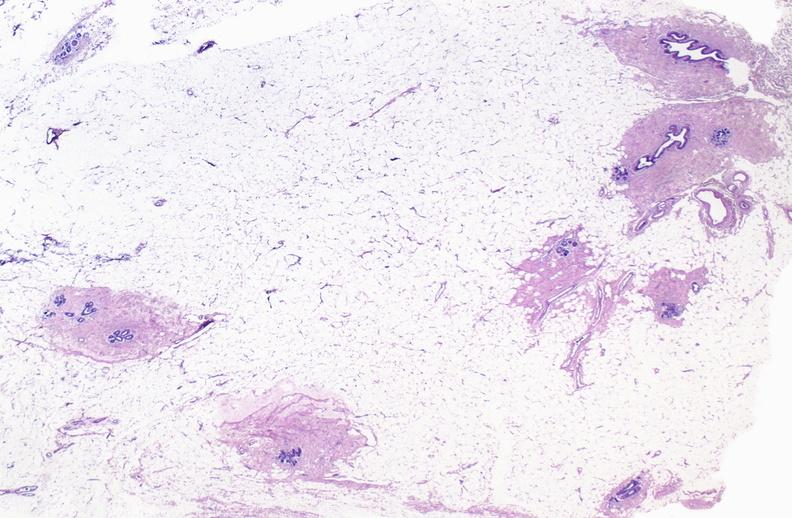where is this area in the body?
Answer the question using a single word or phrase. Breast 